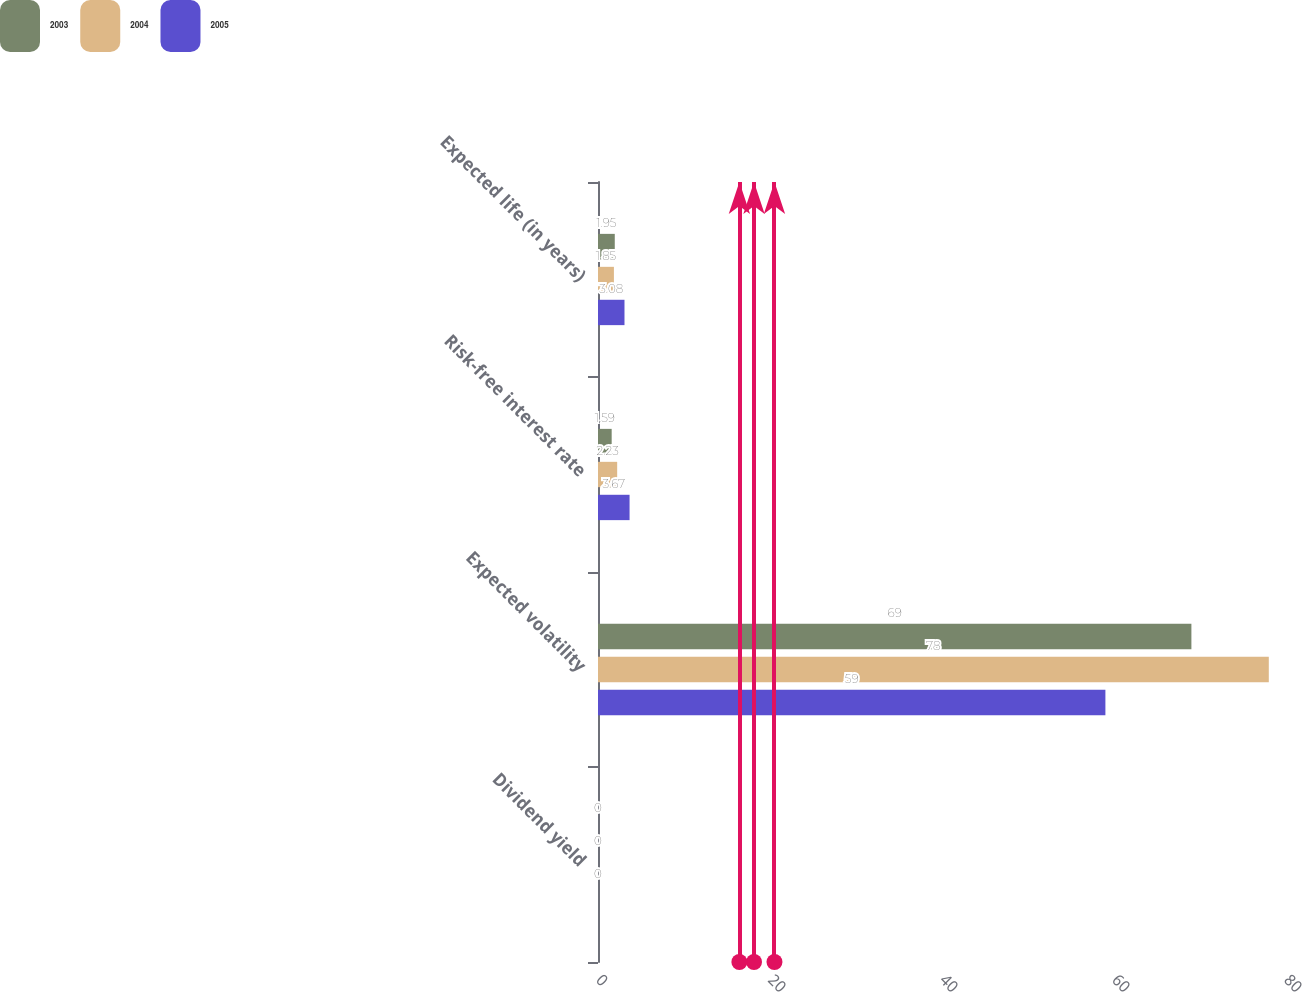Convert chart to OTSL. <chart><loc_0><loc_0><loc_500><loc_500><stacked_bar_chart><ecel><fcel>Dividend yield<fcel>Expected volatility<fcel>Risk-free interest rate<fcel>Expected life (in years)<nl><fcel>2003<fcel>0<fcel>69<fcel>1.59<fcel>1.95<nl><fcel>2004<fcel>0<fcel>78<fcel>2.23<fcel>1.85<nl><fcel>2005<fcel>0<fcel>59<fcel>3.67<fcel>3.08<nl></chart> 